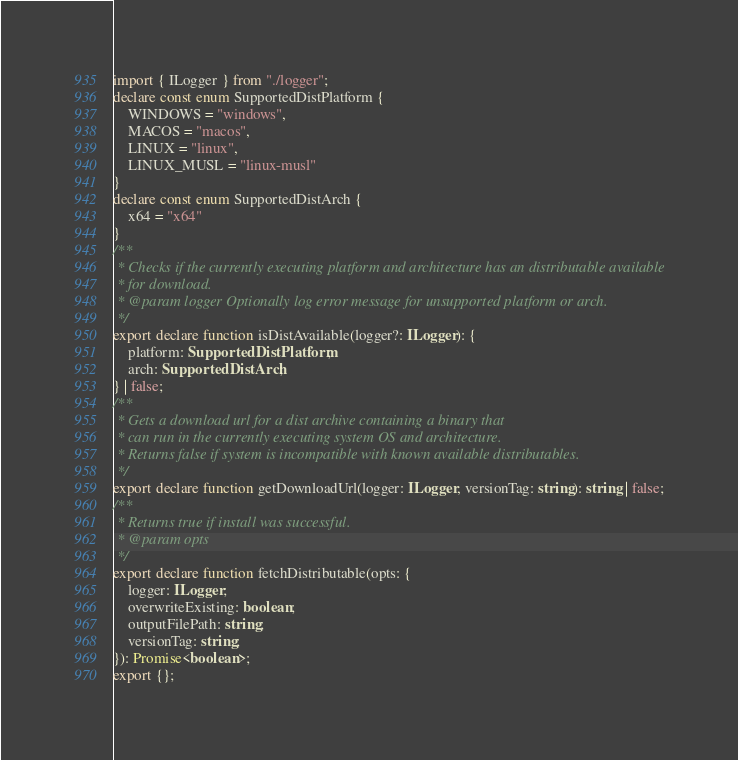Convert code to text. <code><loc_0><loc_0><loc_500><loc_500><_TypeScript_>import { ILogger } from "./logger";
declare const enum SupportedDistPlatform {
    WINDOWS = "windows",
    MACOS = "macos",
    LINUX = "linux",
    LINUX_MUSL = "linux-musl"
}
declare const enum SupportedDistArch {
    x64 = "x64"
}
/**
 * Checks if the currently executing platform and architecture has an distributable available
 * for download.
 * @param logger Optionally log error message for unsupported platform or arch.
 */
export declare function isDistAvailable(logger?: ILogger): {
    platform: SupportedDistPlatform;
    arch: SupportedDistArch;
} | false;
/**
 * Gets a download url for a dist archive containing a binary that
 * can run in the currently executing system OS and architecture.
 * Returns false if system is incompatible with known available distributables.
 */
export declare function getDownloadUrl(logger: ILogger, versionTag: string): string | false;
/**
 * Returns true if install was successful.
 * @param opts
 */
export declare function fetchDistributable(opts: {
    logger: ILogger;
    overwriteExisting: boolean;
    outputFilePath: string;
    versionTag: string;
}): Promise<boolean>;
export {};
</code> 